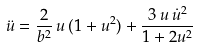<formula> <loc_0><loc_0><loc_500><loc_500>\ddot { u } = \frac { 2 } { b ^ { 2 } } \, u \, ( 1 + u ^ { 2 } ) + \frac { 3 \, u \, \dot { u } ^ { 2 } } { 1 + 2 u ^ { 2 } }</formula> 